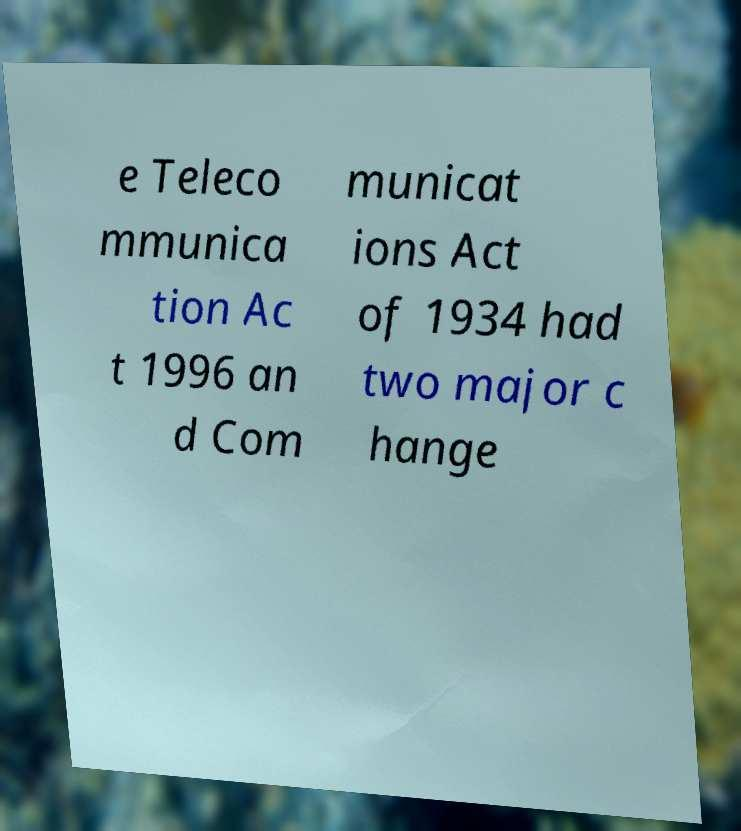Can you read and provide the text displayed in the image?This photo seems to have some interesting text. Can you extract and type it out for me? e Teleco mmunica tion Ac t 1996 an d Com municat ions Act of 1934 had two major c hange 